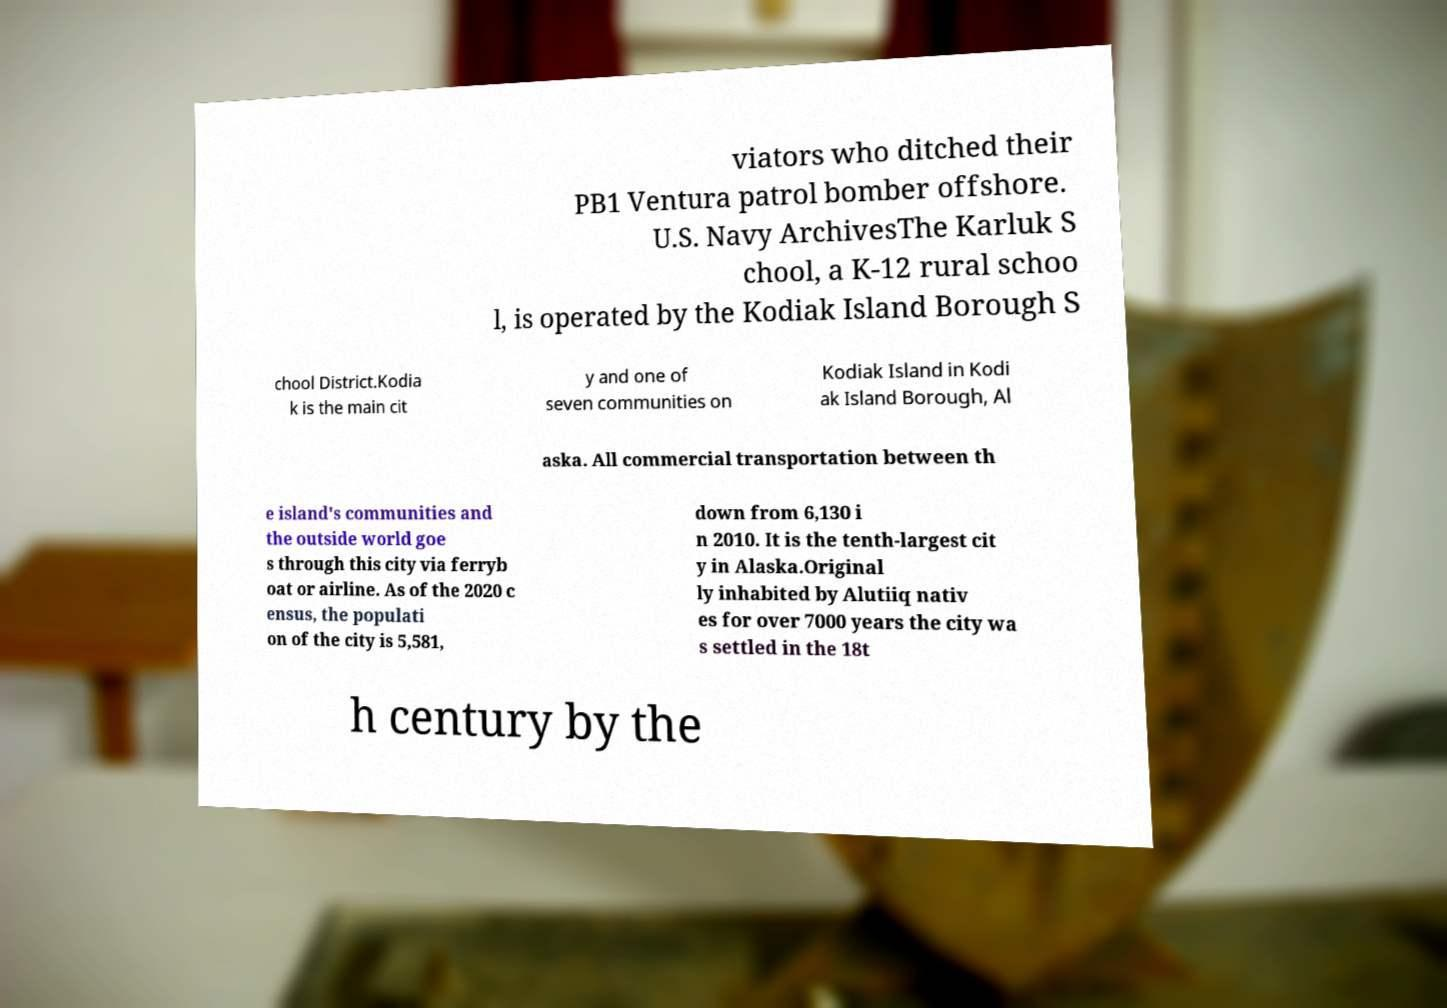Please identify and transcribe the text found in this image. viators who ditched their PB1 Ventura patrol bomber offshore. U.S. Navy ArchivesThe Karluk S chool, a K-12 rural schoo l, is operated by the Kodiak Island Borough S chool District.Kodia k is the main cit y and one of seven communities on Kodiak Island in Kodi ak Island Borough, Al aska. All commercial transportation between th e island's communities and the outside world goe s through this city via ferryb oat or airline. As of the 2020 c ensus, the populati on of the city is 5,581, down from 6,130 i n 2010. It is the tenth-largest cit y in Alaska.Original ly inhabited by Alutiiq nativ es for over 7000 years the city wa s settled in the 18t h century by the 